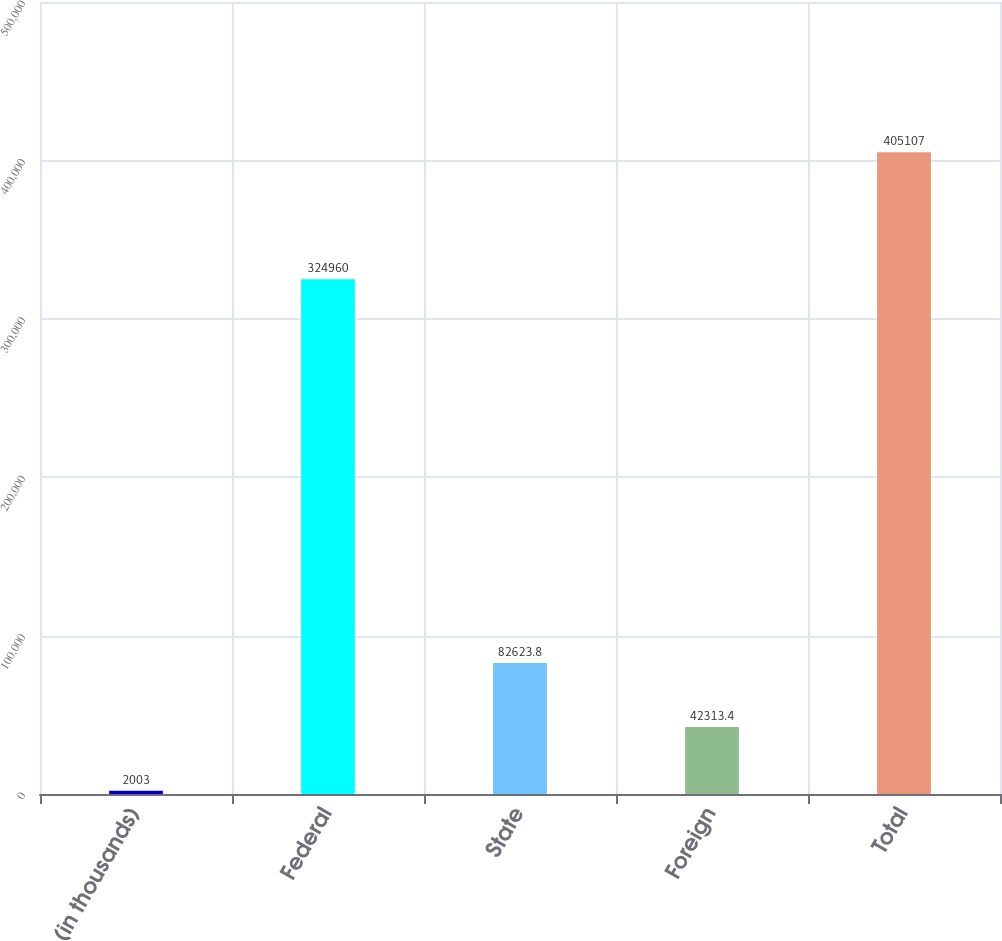<chart> <loc_0><loc_0><loc_500><loc_500><bar_chart><fcel>(in thousands)<fcel>Federal<fcel>State<fcel>Foreign<fcel>Total<nl><fcel>2003<fcel>324960<fcel>82623.8<fcel>42313.4<fcel>405107<nl></chart> 